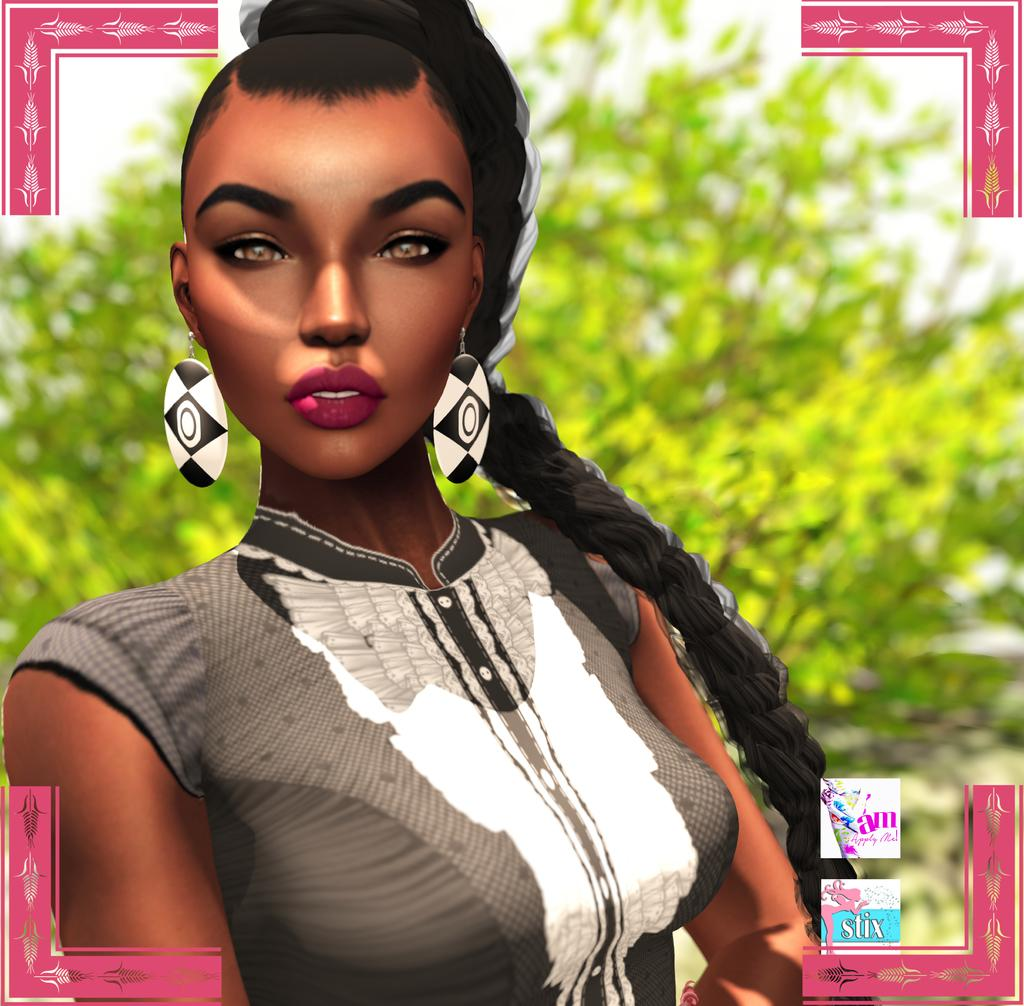What type of media is the image? The image is an animation. Can you describe the lady in the image? The lady in the image is wearing earrings. How is the background of the image depicted? The background of the image is blurred and green. How many babies are holding spoons in the image? There are no babies or spoons present in the image; it features an animated lady with a blurred green background. 